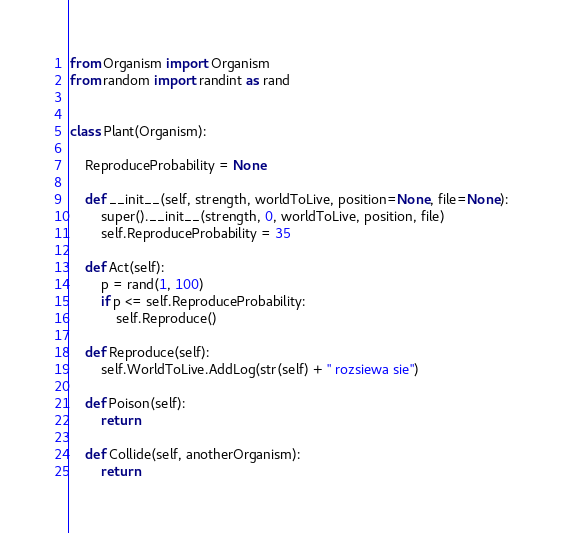Convert code to text. <code><loc_0><loc_0><loc_500><loc_500><_Python_>from Organism import Organism
from random import randint as rand


class Plant(Organism):

    ReproduceProbability = None

    def __init__(self, strength, worldToLive, position=None, file=None):
        super().__init__(strength, 0, worldToLive, position, file)
        self.ReproduceProbability = 35

    def Act(self):
        p = rand(1, 100)
        if p <= self.ReproduceProbability:
            self.Reproduce()

    def Reproduce(self):
        self.WorldToLive.AddLog(str(self) + " rozsiewa sie")

    def Poison(self):
        return

    def Collide(self, anotherOrganism):
        return

</code> 